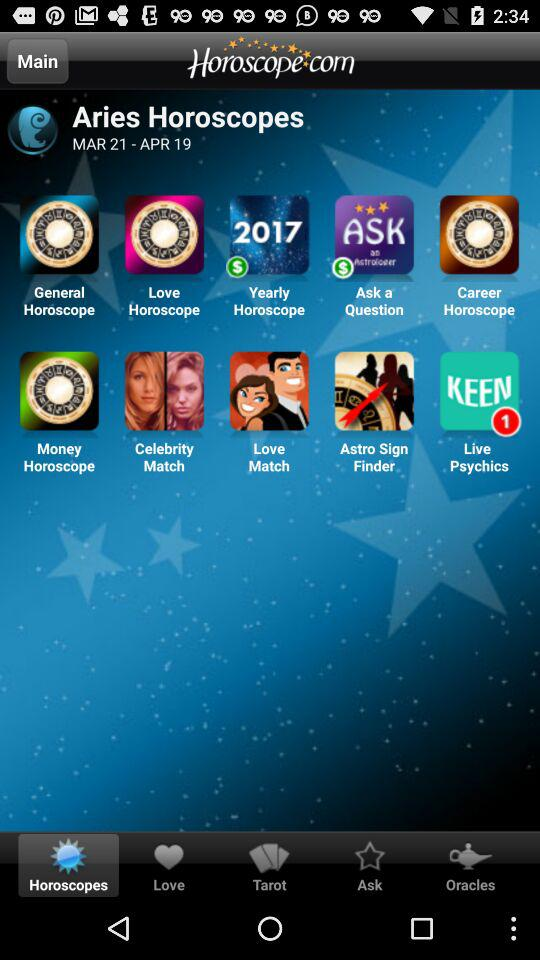What is the duration of Aries Horoscopes? The duration of Aries Horoscopes is from March 21 to April 19. 